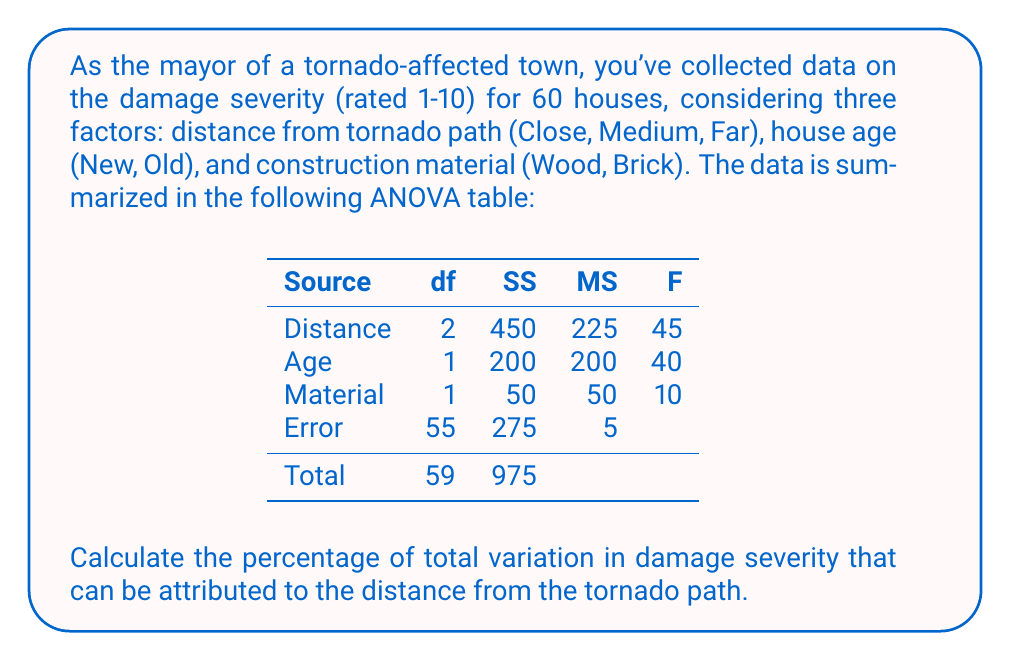Show me your answer to this math problem. To calculate the percentage of total variation attributed to distance, we need to follow these steps:

1) First, identify the Sum of Squares (SS) for distance and the total SS:
   SS(Distance) = 450
   SS(Total) = 975

2) The percentage of variation explained by distance is calculated as:

   $$\text{Percentage} = \frac{\text{SS(Distance)}}{\text{SS(Total)}} \times 100\%$$

3) Substituting the values:

   $$\text{Percentage} = \frac{450}{975} \times 100\%$$

4) Simplify:
   
   $$\text{Percentage} = 0.4615384615 \times 100\% = 46.15\%$$

Thus, approximately 46.15% of the total variation in damage severity can be attributed to the distance from the tornado path.
Answer: 46.15% 